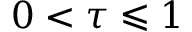Convert formula to latex. <formula><loc_0><loc_0><loc_500><loc_500>0 < \tau \leqslant 1</formula> 